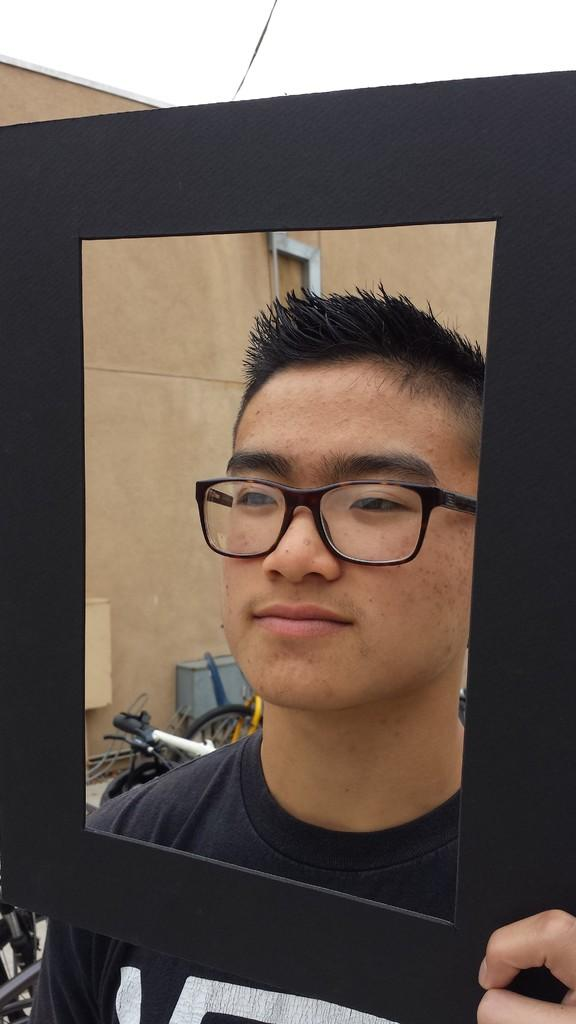Who is present in the image? There is a man in the image. What is the man wearing? The man is wearing spectacles. What is the man doing in the image? The man is standing and holding a black frame. Can you describe any other elements in the image? There is a wire in the image, and there are objects on the ground and attached to the wall. What type of toy can be seen in the man's hand in the image? There is no toy present in the man's hand or in the image. What color is the owl perched on the man's shoulder in the image? There is no owl present in the image. 